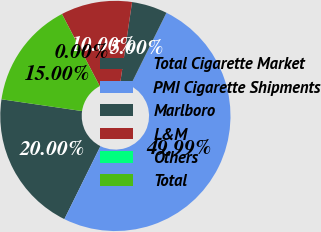Convert chart to OTSL. <chart><loc_0><loc_0><loc_500><loc_500><pie_chart><fcel>Total Cigarette Market<fcel>PMI Cigarette Shipments<fcel>Marlboro<fcel>L&M<fcel>Others<fcel>Total<nl><fcel>20.0%<fcel>49.99%<fcel>5.0%<fcel>10.0%<fcel>0.0%<fcel>15.0%<nl></chart> 